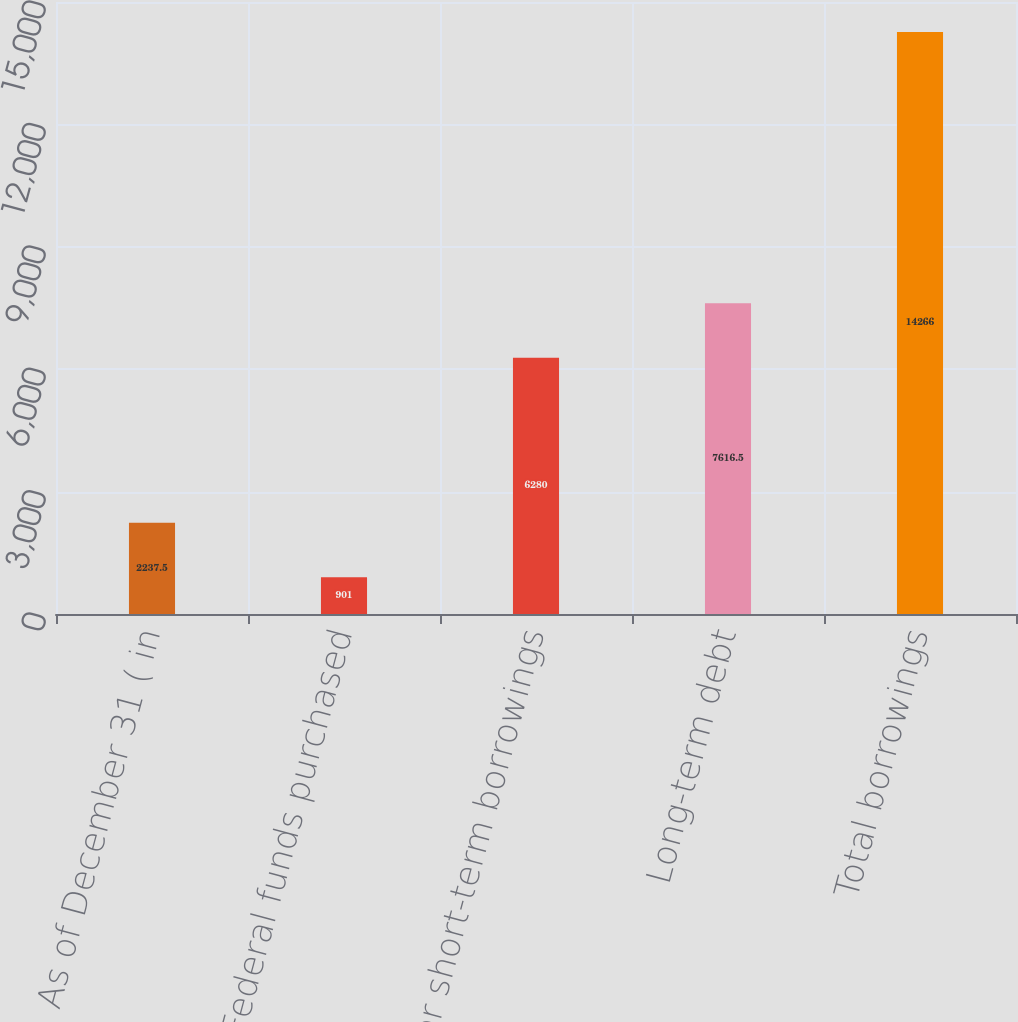<chart> <loc_0><loc_0><loc_500><loc_500><bar_chart><fcel>As of December 31 ( in<fcel>Federal funds purchased<fcel>Other short-term borrowings<fcel>Long-term debt<fcel>Total borrowings<nl><fcel>2237.5<fcel>901<fcel>6280<fcel>7616.5<fcel>14266<nl></chart> 